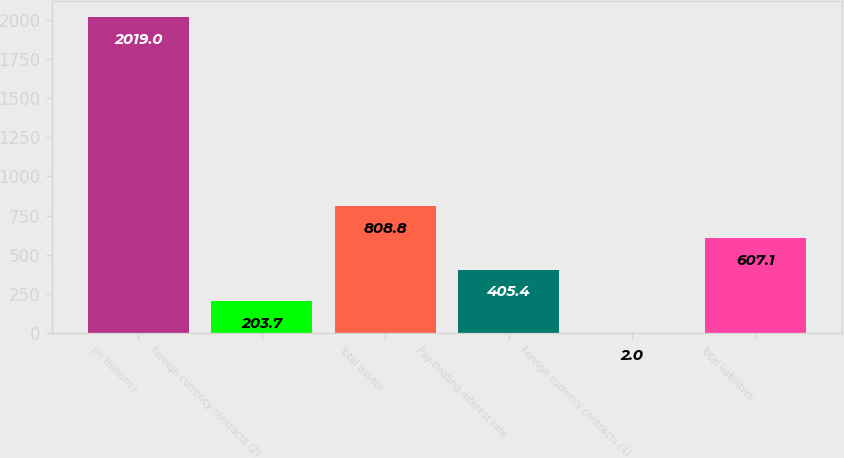Convert chart. <chart><loc_0><loc_0><loc_500><loc_500><bar_chart><fcel>(in millions)<fcel>Foreign currency contracts (2)<fcel>Total assets<fcel>Pay-floating interest rate<fcel>Foreign currency contracts (4)<fcel>Total liabilities<nl><fcel>2019<fcel>203.7<fcel>808.8<fcel>405.4<fcel>2<fcel>607.1<nl></chart> 